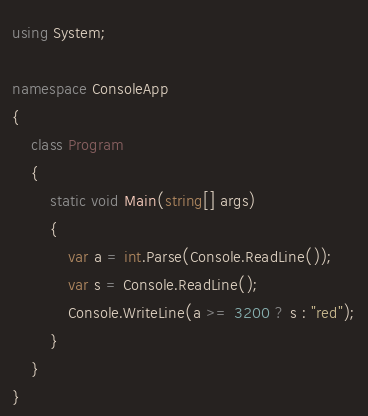Convert code to text. <code><loc_0><loc_0><loc_500><loc_500><_C#_>using System;

namespace ConsoleApp
{
    class Program
    {
        static void Main(string[] args)
        {
            var a = int.Parse(Console.ReadLine());
            var s = Console.ReadLine();
            Console.WriteLine(a >= 3200 ? s : "red");
        }
    }
}</code> 